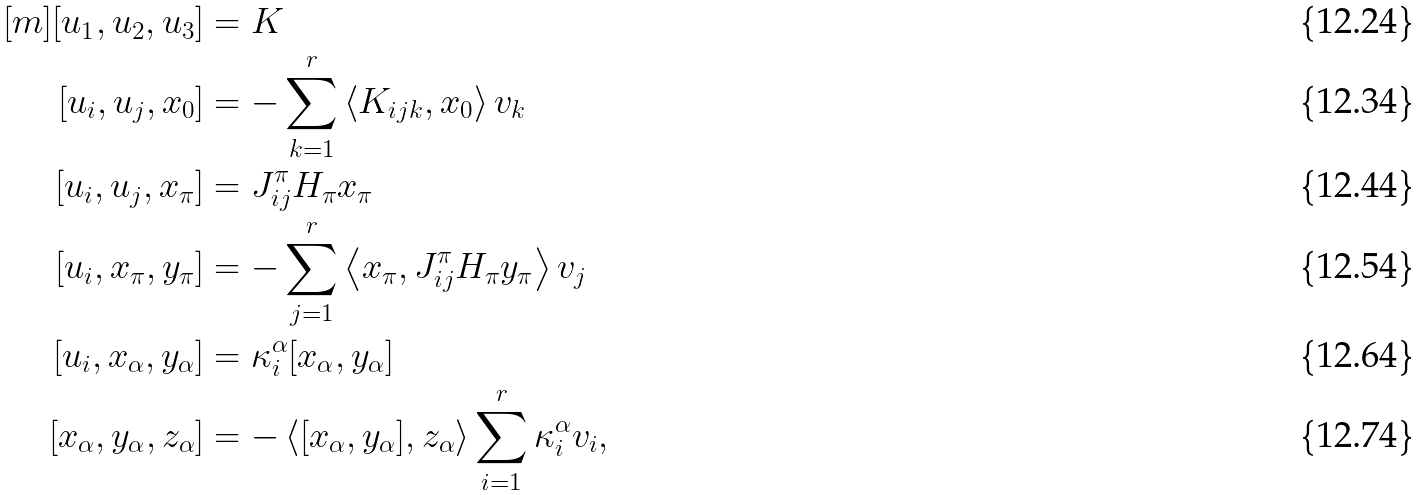Convert formula to latex. <formula><loc_0><loc_0><loc_500><loc_500>[ m ] [ u _ { 1 } , u _ { 2 } , u _ { 3 } ] & = K \\ [ u _ { i } , u _ { j } , x _ { 0 } ] & = - \sum _ { k = 1 } ^ { r } \left < K _ { i j k } , x _ { 0 } \right > v _ { k } \\ [ u _ { i } , u _ { j } , x _ { \pi } ] & = J ^ { \pi } _ { i j } H _ { \pi } x _ { \pi } \\ [ u _ { i } , x _ { \pi } , y _ { \pi } ] & = - \sum _ { j = 1 } ^ { r } \left < x _ { \pi } , J ^ { \pi } _ { i j } H _ { \pi } y _ { \pi } \right > v _ { j } \\ [ u _ { i } , x _ { \alpha } , y _ { \alpha } ] & = \kappa _ { i } ^ { \alpha } [ x _ { \alpha } , y _ { \alpha } ] \\ [ x _ { \alpha } , y _ { \alpha } , z _ { \alpha } ] & = - \left < [ x _ { \alpha } , y _ { \alpha } ] , z _ { \alpha } \right > \sum _ { i = 1 } ^ { r } \kappa _ { i } ^ { \alpha } v _ { i } ,</formula> 